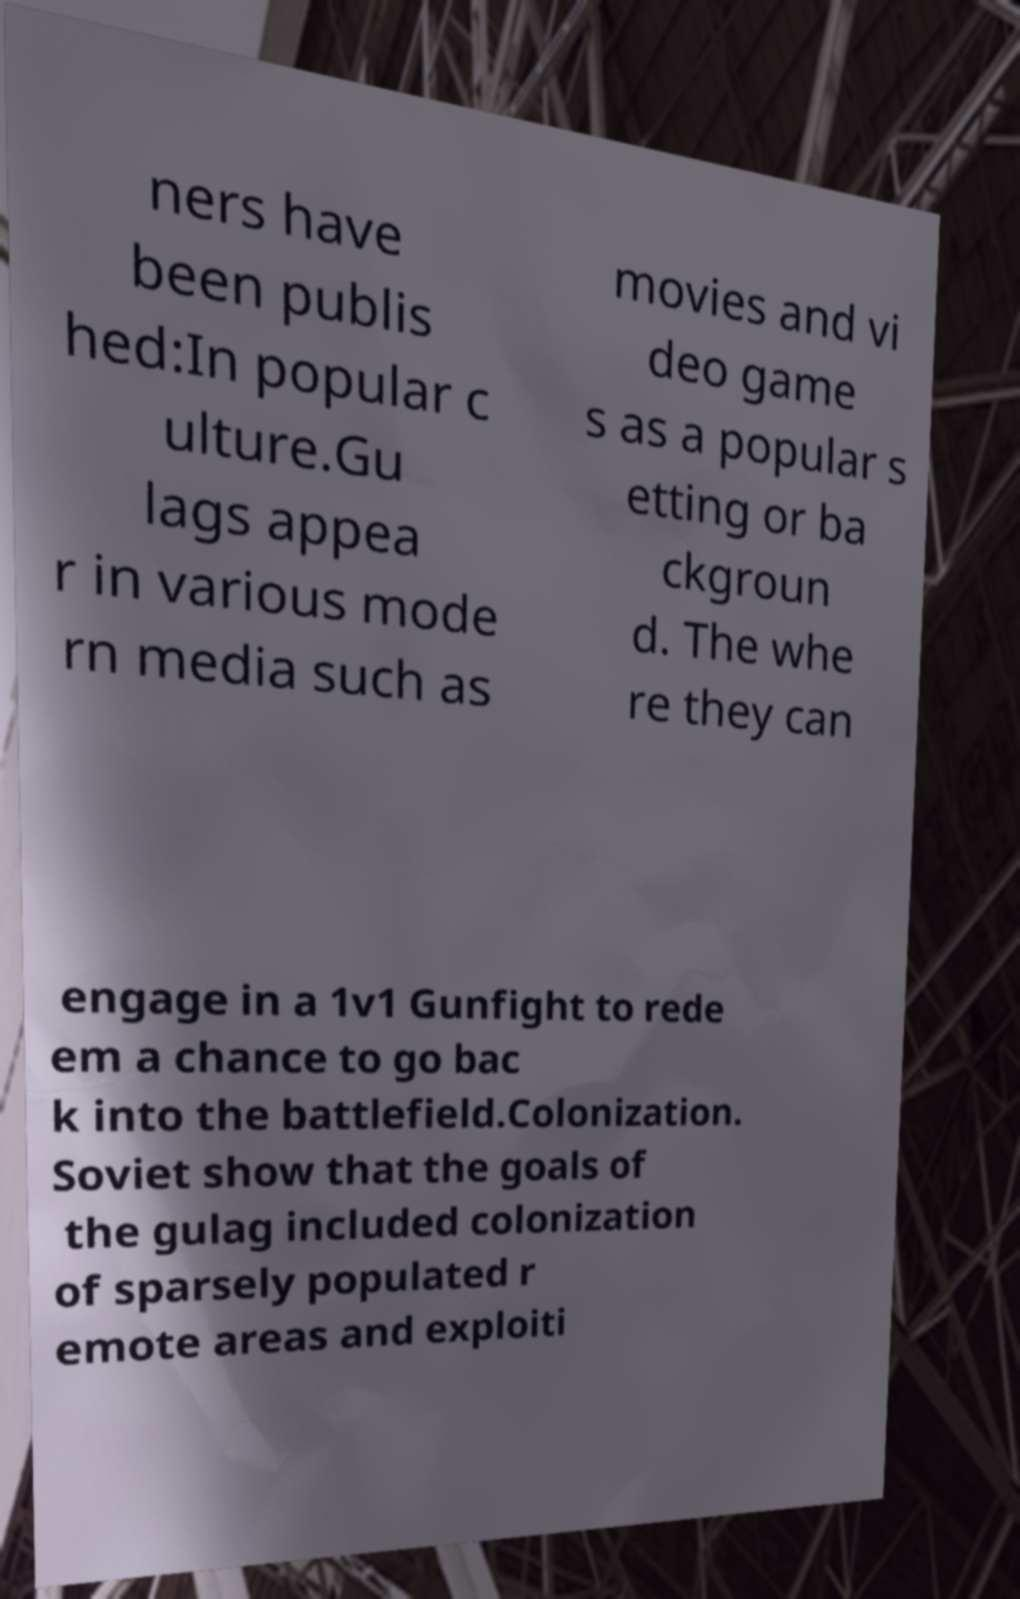Could you extract and type out the text from this image? ners have been publis hed:In popular c ulture.Gu lags appea r in various mode rn media such as movies and vi deo game s as a popular s etting or ba ckgroun d. The whe re they can engage in a 1v1 Gunfight to rede em a chance to go bac k into the battlefield.Colonization. Soviet show that the goals of the gulag included colonization of sparsely populated r emote areas and exploiti 